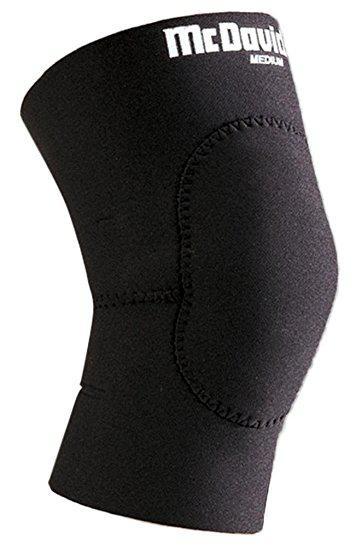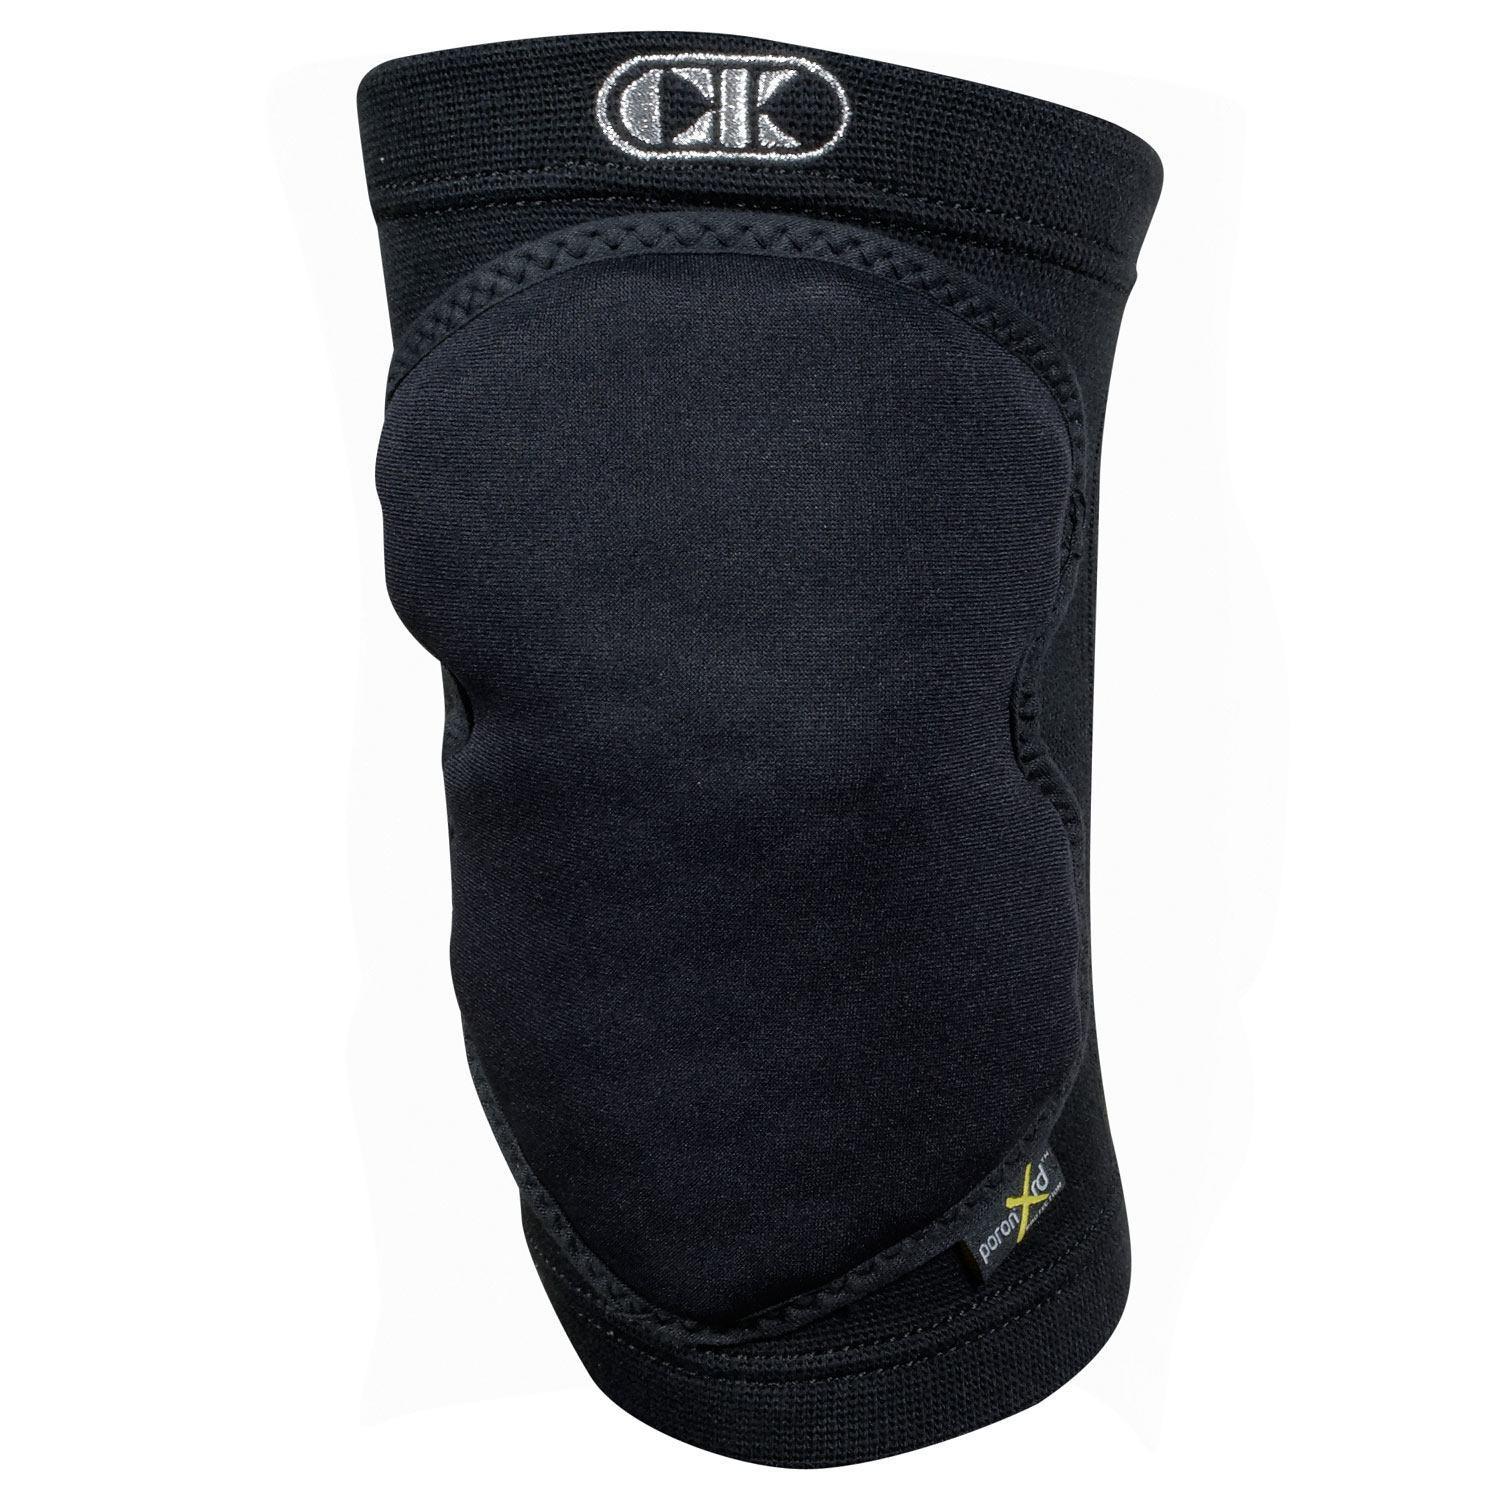The first image is the image on the left, the second image is the image on the right. Examine the images to the left and right. Is the description "Left image features one right-facing kneepad." accurate? Answer yes or no. Yes. 